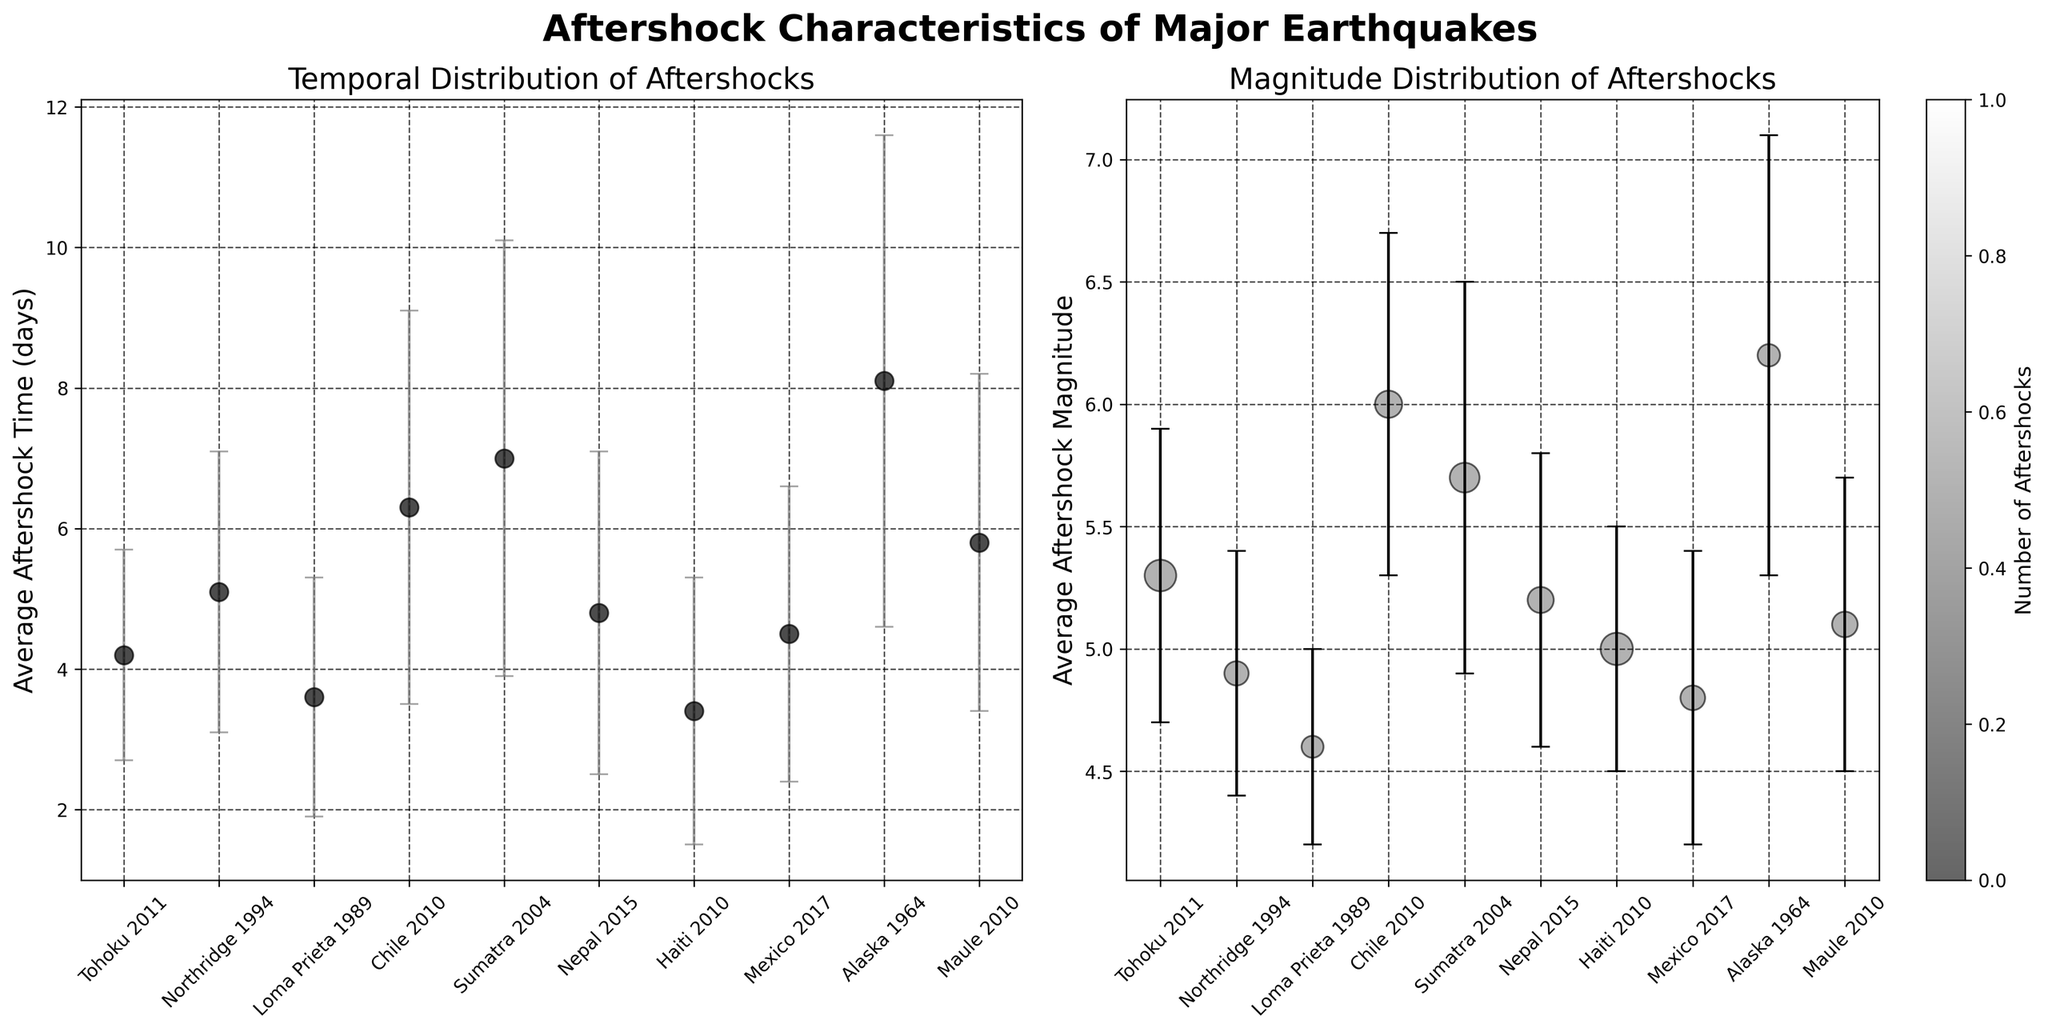What's the title of the figure? The title is displayed at the top of the figure. It says 'Aftershock Characteristics of Major Earthquakes'.
Answer: Aftershock Characteristics of Major Earthquakes How is the average aftershock time for each earthquake represented? The average aftershock time is shown on the y-axis of the first subplot, with each earthquake labeled along the x-axis. Points mark the averages, and vertical lines through these points show the standard deviation.
Answer: Points with error bars Which earthquake has the highest average aftershock magnitude? The second subplot shows the average aftershock magnitude on the y-axis, with each earthquake labeled on the x-axis. The highest point represents the highest average magnitude. Looking at the plot, Alaska 1964 has the highest average aftershock magnitude.
Answer: Alaska 1964 How many aftershocks were recorded for the Haiti 2010 earthquake? The number of aftershocks is indicated by the size of the scatter points in the second subplot. Larger points indicate more aftershocks. By identifying Haiti 2010 in the second plot and checking its size, we can see it is the largest, corresponding to 158 aftershocks.
Answer: 158 Which earthquake has the least variation in aftershock time? The variation in aftershock time is represented by the length of the error bars in the first subplot. The shortest error bars indicate the least variation. Haiti 2010 has the shortest error bars for average aftershock time.
Answer: Haiti 2010 Compare average aftershock times for Tohoku 2011 and Chile 2010. Which is higher? By examining the first subplot, we look for the points corresponding to Tohoku 2011 and Chile 2010. Tohoku 2011's average aftershock time is approximately 4.2 days, while Chile 2010's is approximately 6.3 days. Chile 2010 has a higher average aftershock time.
Answer: Chile 2010 What does the colorbar in the second subplot represent? The colorbar next to the second subplot indicates it shows the number of aftershocks. Different shades correspond to different counts, matching them to the scatter points' sizes.
Answer: Number of aftershocks Does Tohoku 2011 have a higher or lower average aftershock magnitude than Mexico 2017? By comparing their positions along the y-axis in the second subplot, we see Tohoku 2011 at around 5.3 and Mexico 2017 at around 4.8. Tohoku 2011 has a higher average aftershock magnitude.
Answer: Higher Which earthquake has the largest standard deviation in aftershock time? In the first subplot, the largest error bars indicate the highest standard deviation. Alaska 1964 has notably longer error bars compared to others, showing the largest standard deviation in aftershock time.
Answer: Alaska 1964 What's the difference in average aftershock time between the Nepal 2015 and Haiti 2010 earthquakes? Nepal 2015 has an average aftershock time of 4.8 days, and Haiti 2010 has 3.4 days. The difference is 4.8 - 3.4 = 1.4 days.
Answer: 1.4 days 